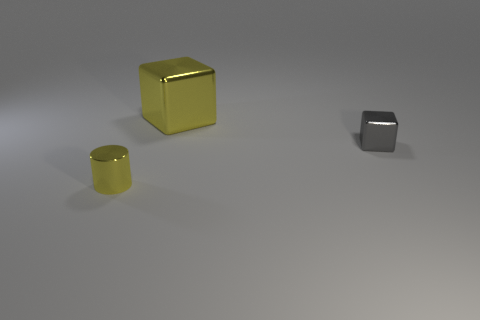Add 3 large brown cylinders. How many objects exist? 6 Subtract all cubes. How many objects are left? 1 Subtract all purple cylinders. Subtract all tiny yellow objects. How many objects are left? 2 Add 2 cylinders. How many cylinders are left? 3 Add 3 yellow blocks. How many yellow blocks exist? 4 Subtract 0 cyan balls. How many objects are left? 3 